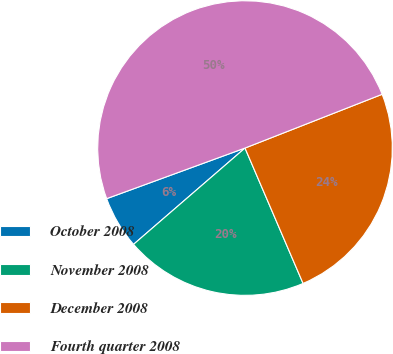Convert chart. <chart><loc_0><loc_0><loc_500><loc_500><pie_chart><fcel>October 2008<fcel>November 2008<fcel>December 2008<fcel>Fourth quarter 2008<nl><fcel>5.76%<fcel>20.11%<fcel>24.5%<fcel>49.64%<nl></chart> 